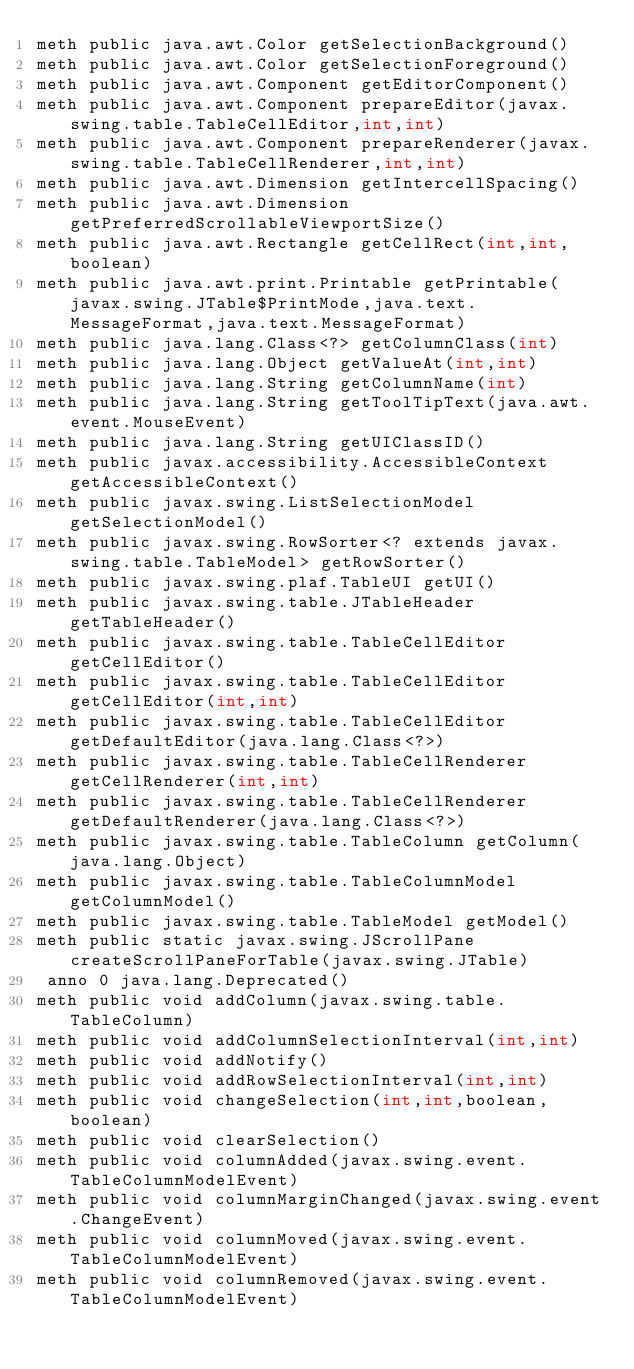<code> <loc_0><loc_0><loc_500><loc_500><_SML_>meth public java.awt.Color getSelectionBackground()
meth public java.awt.Color getSelectionForeground()
meth public java.awt.Component getEditorComponent()
meth public java.awt.Component prepareEditor(javax.swing.table.TableCellEditor,int,int)
meth public java.awt.Component prepareRenderer(javax.swing.table.TableCellRenderer,int,int)
meth public java.awt.Dimension getIntercellSpacing()
meth public java.awt.Dimension getPreferredScrollableViewportSize()
meth public java.awt.Rectangle getCellRect(int,int,boolean)
meth public java.awt.print.Printable getPrintable(javax.swing.JTable$PrintMode,java.text.MessageFormat,java.text.MessageFormat)
meth public java.lang.Class<?> getColumnClass(int)
meth public java.lang.Object getValueAt(int,int)
meth public java.lang.String getColumnName(int)
meth public java.lang.String getToolTipText(java.awt.event.MouseEvent)
meth public java.lang.String getUIClassID()
meth public javax.accessibility.AccessibleContext getAccessibleContext()
meth public javax.swing.ListSelectionModel getSelectionModel()
meth public javax.swing.RowSorter<? extends javax.swing.table.TableModel> getRowSorter()
meth public javax.swing.plaf.TableUI getUI()
meth public javax.swing.table.JTableHeader getTableHeader()
meth public javax.swing.table.TableCellEditor getCellEditor()
meth public javax.swing.table.TableCellEditor getCellEditor(int,int)
meth public javax.swing.table.TableCellEditor getDefaultEditor(java.lang.Class<?>)
meth public javax.swing.table.TableCellRenderer getCellRenderer(int,int)
meth public javax.swing.table.TableCellRenderer getDefaultRenderer(java.lang.Class<?>)
meth public javax.swing.table.TableColumn getColumn(java.lang.Object)
meth public javax.swing.table.TableColumnModel getColumnModel()
meth public javax.swing.table.TableModel getModel()
meth public static javax.swing.JScrollPane createScrollPaneForTable(javax.swing.JTable)
 anno 0 java.lang.Deprecated()
meth public void addColumn(javax.swing.table.TableColumn)
meth public void addColumnSelectionInterval(int,int)
meth public void addNotify()
meth public void addRowSelectionInterval(int,int)
meth public void changeSelection(int,int,boolean,boolean)
meth public void clearSelection()
meth public void columnAdded(javax.swing.event.TableColumnModelEvent)
meth public void columnMarginChanged(javax.swing.event.ChangeEvent)
meth public void columnMoved(javax.swing.event.TableColumnModelEvent)
meth public void columnRemoved(javax.swing.event.TableColumnModelEvent)</code> 